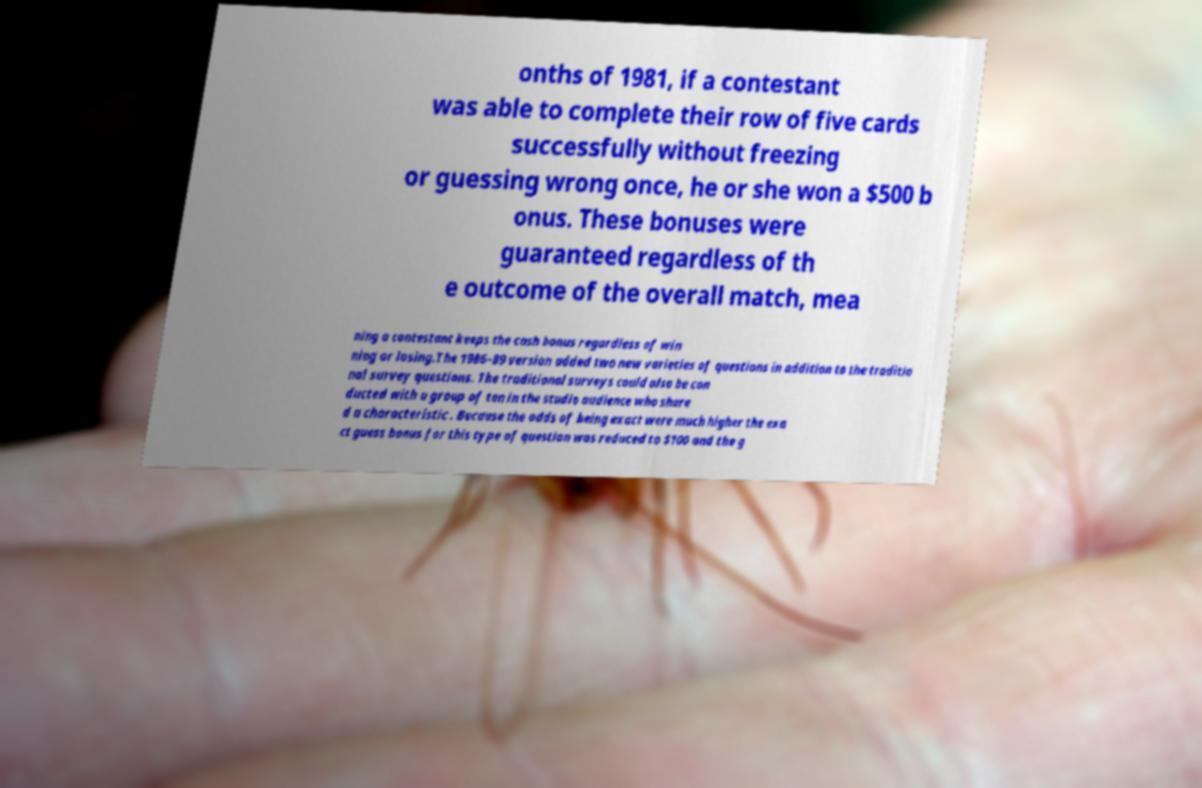For documentation purposes, I need the text within this image transcribed. Could you provide that? onths of 1981, if a contestant was able to complete their row of five cards successfully without freezing or guessing wrong once, he or she won a $500 b onus. These bonuses were guaranteed regardless of th e outcome of the overall match, mea ning a contestant keeps the cash bonus regardless of win ning or losing.The 1986–89 version added two new varieties of questions in addition to the traditio nal survey questions. The traditional surveys could also be con ducted with a group of ten in the studio audience who share d a characteristic . Because the odds of being exact were much higher the exa ct guess bonus for this type of question was reduced to $100 and the g 